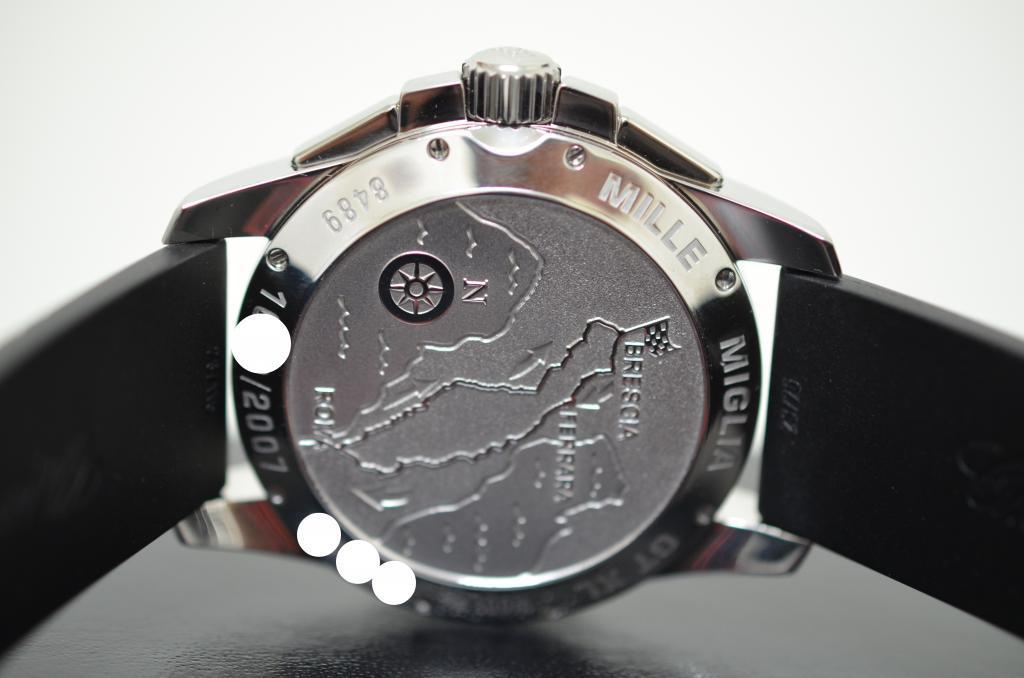<image>
Render a clear and concise summary of the photo. Watch that has the company Mille Miglia with the text 8489, 2007. 